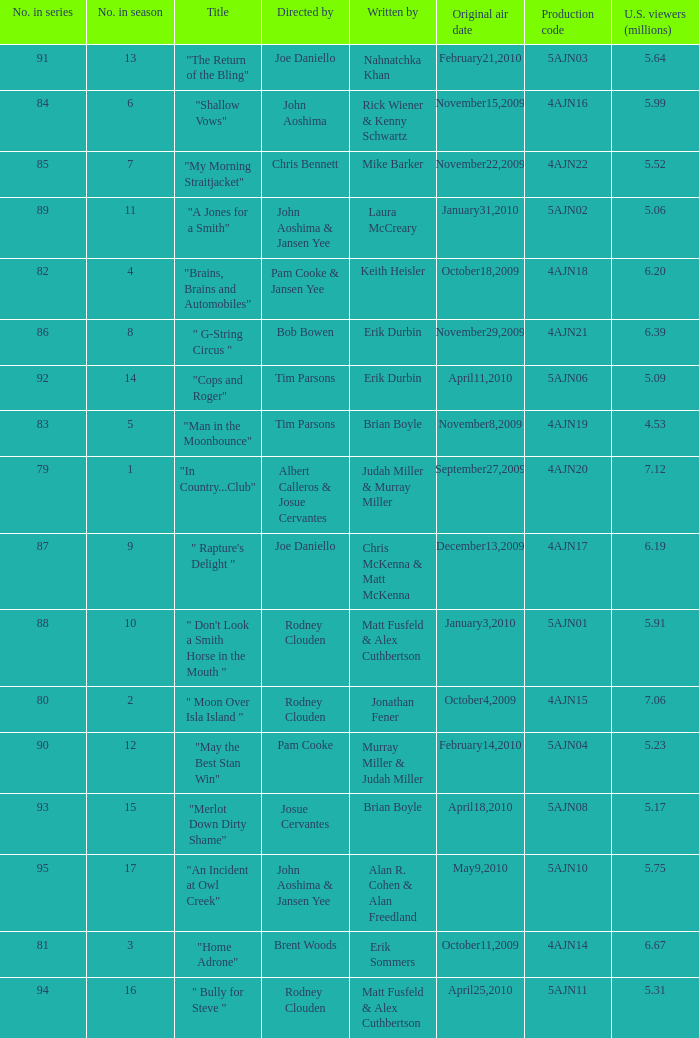Name who wrote number 88 Matt Fusfeld & Alex Cuthbertson. 